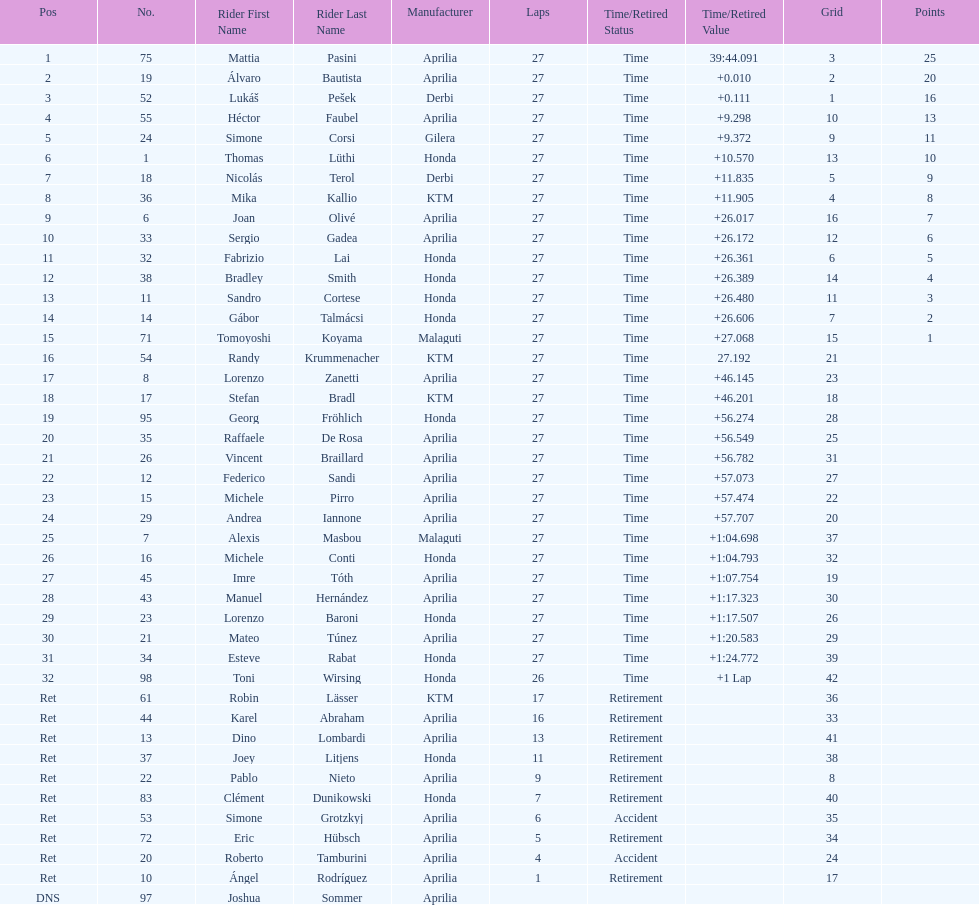How many racers did not use an aprilia or a honda? 9. 